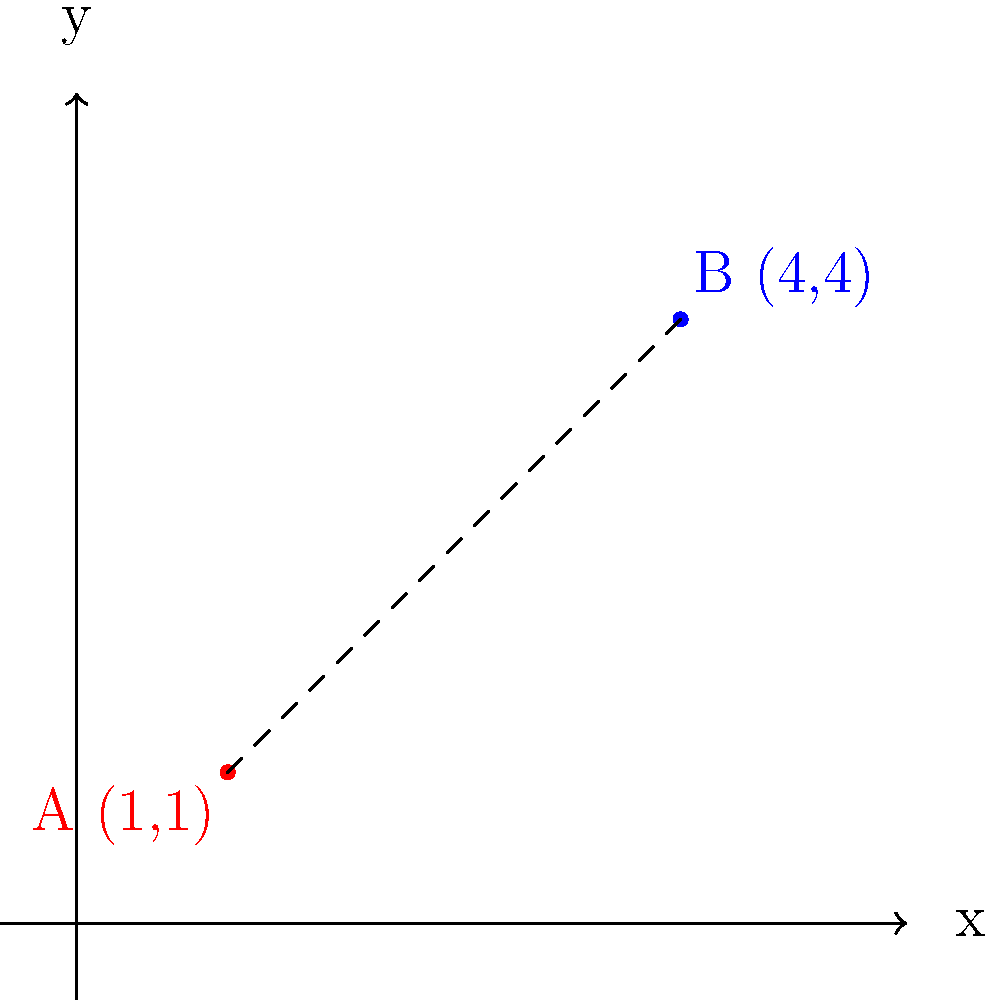In a historical map of two significant cities during the American Civil War, City A is located at coordinates (1,1) and City B at (4,4) on a Cartesian plane where each unit represents 50 miles. What is the straight-line distance between these two cities? How might this distance have influenced military strategy and communication during the war? To solve this problem, we'll use the distance formula derived from the Pythagorean theorem:

1) The distance formula is: 
   $$d = \sqrt{(x_2-x_1)^2 + (y_2-y_1)^2}$$

2) We have:
   City A: $(x_1,y_1) = (1,1)$
   City B: $(x_2,y_2) = (4,4)$

3) Plugging these into the formula:
   $$d = \sqrt{(4-1)^2 + (4-1)^2}$$

4) Simplify:
   $$d = \sqrt{3^2 + 3^2} = \sqrt{9 + 9} = \sqrt{18}$$

5) Simplify further:
   $$d = 3\sqrt{2}$$

6) Remember that each unit represents 50 miles, so we multiply our result by 50:
   $$\text{Distance} = 3\sqrt{2} * 50 = 150\sqrt{2} \approx 212.13 \text{ miles}$$

Historical context:
This distance of about 212 miles would have been significant during the Civil War. It would have taken several days to travel by horse or foot, affecting troop movements and communication speed. Telegraphs could transmit messages quickly, but the physical distance would still impact supply lines and strategic planning. The straight-line distance might not reflect actual travel routes, which would likely be longer due to terrain and existing road networks.
Answer: $150\sqrt{2}$ miles (approximately 212.13 miles) 